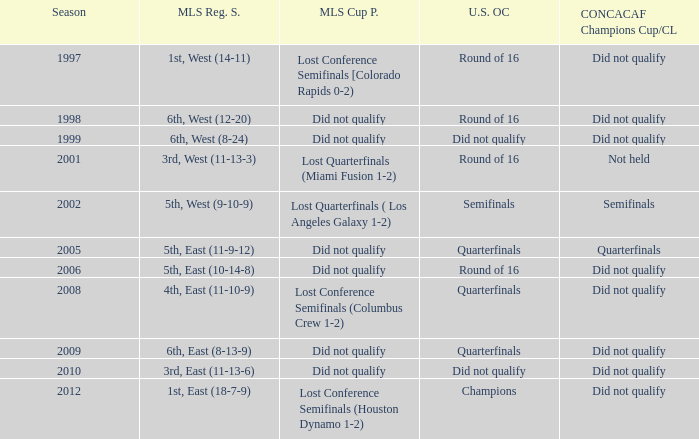What were the placements of the team in regular season when they reached quarterfinals in the U.S. Open Cup but did not qualify for the Concaf Champions Cup? 4th, East (11-10-9), 6th, East (8-13-9). 